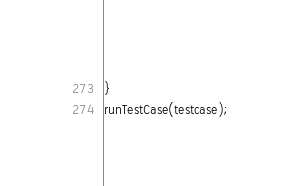Convert code to text. <code><loc_0><loc_0><loc_500><loc_500><_JavaScript_>
}
runTestCase(testcase);
</code> 